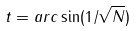<formula> <loc_0><loc_0><loc_500><loc_500>t = a r c \sin ( 1 / \sqrt { N } )</formula> 